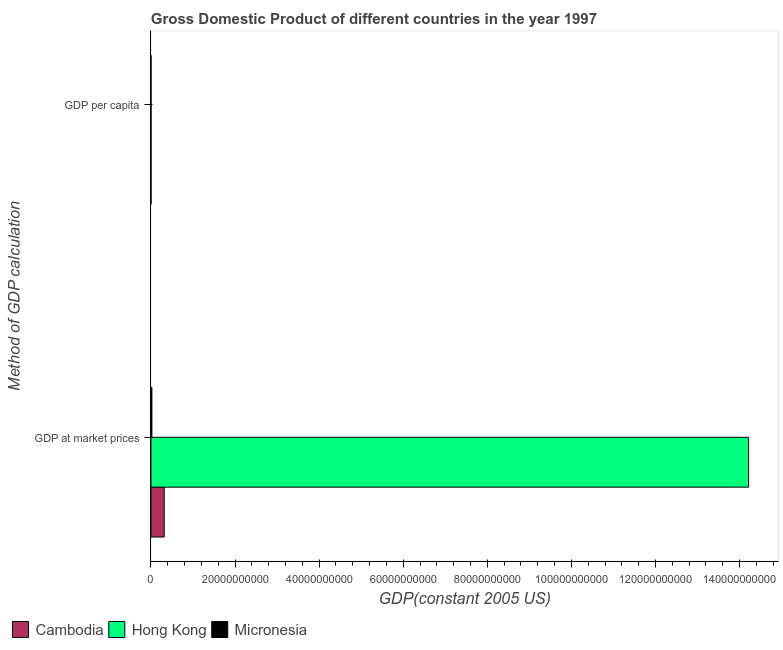How many groups of bars are there?
Give a very brief answer. 2. Are the number of bars per tick equal to the number of legend labels?
Give a very brief answer. Yes. Are the number of bars on each tick of the Y-axis equal?
Give a very brief answer. Yes. What is the label of the 1st group of bars from the top?
Ensure brevity in your answer.  GDP per capita. What is the gdp at market prices in Micronesia?
Your answer should be very brief. 2.22e+08. Across all countries, what is the maximum gdp per capita?
Make the answer very short. 2.19e+04. Across all countries, what is the minimum gdp per capita?
Offer a terse response. 277.83. In which country was the gdp at market prices maximum?
Make the answer very short. Hong Kong. In which country was the gdp per capita minimum?
Make the answer very short. Cambodia. What is the total gdp per capita in the graph?
Give a very brief answer. 2.42e+04. What is the difference between the gdp at market prices in Micronesia and that in Hong Kong?
Offer a terse response. -1.42e+11. What is the difference between the gdp at market prices in Cambodia and the gdp per capita in Hong Kong?
Your answer should be very brief. 3.15e+09. What is the average gdp per capita per country?
Your answer should be compact. 8076.57. What is the difference between the gdp per capita and gdp at market prices in Cambodia?
Ensure brevity in your answer.  -3.15e+09. What is the ratio of the gdp per capita in Micronesia to that in Hong Kong?
Keep it short and to the point. 0.09. Is the gdp at market prices in Hong Kong less than that in Micronesia?
Give a very brief answer. No. In how many countries, is the gdp at market prices greater than the average gdp at market prices taken over all countries?
Give a very brief answer. 1. What does the 1st bar from the top in GDP at market prices represents?
Keep it short and to the point. Micronesia. What does the 2nd bar from the bottom in GDP per capita represents?
Provide a succinct answer. Hong Kong. How many bars are there?
Keep it short and to the point. 6. Does the graph contain grids?
Keep it short and to the point. No. Where does the legend appear in the graph?
Make the answer very short. Bottom left. How many legend labels are there?
Offer a terse response. 3. How are the legend labels stacked?
Your answer should be very brief. Horizontal. What is the title of the graph?
Provide a short and direct response. Gross Domestic Product of different countries in the year 1997. What is the label or title of the X-axis?
Your answer should be compact. GDP(constant 2005 US). What is the label or title of the Y-axis?
Provide a succinct answer. Method of GDP calculation. What is the GDP(constant 2005 US) of Cambodia in GDP at market prices?
Make the answer very short. 3.15e+09. What is the GDP(constant 2005 US) in Hong Kong in GDP at market prices?
Your answer should be compact. 1.42e+11. What is the GDP(constant 2005 US) of Micronesia in GDP at market prices?
Offer a terse response. 2.22e+08. What is the GDP(constant 2005 US) of Cambodia in GDP per capita?
Provide a succinct answer. 277.83. What is the GDP(constant 2005 US) of Hong Kong in GDP per capita?
Offer a very short reply. 2.19e+04. What is the GDP(constant 2005 US) of Micronesia in GDP per capita?
Your response must be concise. 2047.5. Across all Method of GDP calculation, what is the maximum GDP(constant 2005 US) in Cambodia?
Your answer should be compact. 3.15e+09. Across all Method of GDP calculation, what is the maximum GDP(constant 2005 US) in Hong Kong?
Offer a very short reply. 1.42e+11. Across all Method of GDP calculation, what is the maximum GDP(constant 2005 US) of Micronesia?
Make the answer very short. 2.22e+08. Across all Method of GDP calculation, what is the minimum GDP(constant 2005 US) of Cambodia?
Provide a short and direct response. 277.83. Across all Method of GDP calculation, what is the minimum GDP(constant 2005 US) of Hong Kong?
Ensure brevity in your answer.  2.19e+04. Across all Method of GDP calculation, what is the minimum GDP(constant 2005 US) in Micronesia?
Ensure brevity in your answer.  2047.5. What is the total GDP(constant 2005 US) of Cambodia in the graph?
Provide a short and direct response. 3.15e+09. What is the total GDP(constant 2005 US) of Hong Kong in the graph?
Offer a very short reply. 1.42e+11. What is the total GDP(constant 2005 US) of Micronesia in the graph?
Make the answer very short. 2.22e+08. What is the difference between the GDP(constant 2005 US) in Cambodia in GDP at market prices and that in GDP per capita?
Provide a short and direct response. 3.15e+09. What is the difference between the GDP(constant 2005 US) in Hong Kong in GDP at market prices and that in GDP per capita?
Offer a terse response. 1.42e+11. What is the difference between the GDP(constant 2005 US) in Micronesia in GDP at market prices and that in GDP per capita?
Your response must be concise. 2.22e+08. What is the difference between the GDP(constant 2005 US) of Cambodia in GDP at market prices and the GDP(constant 2005 US) of Hong Kong in GDP per capita?
Give a very brief answer. 3.15e+09. What is the difference between the GDP(constant 2005 US) in Cambodia in GDP at market prices and the GDP(constant 2005 US) in Micronesia in GDP per capita?
Provide a succinct answer. 3.15e+09. What is the difference between the GDP(constant 2005 US) in Hong Kong in GDP at market prices and the GDP(constant 2005 US) in Micronesia in GDP per capita?
Your answer should be very brief. 1.42e+11. What is the average GDP(constant 2005 US) of Cambodia per Method of GDP calculation?
Ensure brevity in your answer.  1.58e+09. What is the average GDP(constant 2005 US) of Hong Kong per Method of GDP calculation?
Offer a terse response. 7.11e+1. What is the average GDP(constant 2005 US) in Micronesia per Method of GDP calculation?
Give a very brief answer. 1.11e+08. What is the difference between the GDP(constant 2005 US) of Cambodia and GDP(constant 2005 US) of Hong Kong in GDP at market prices?
Offer a very short reply. -1.39e+11. What is the difference between the GDP(constant 2005 US) in Cambodia and GDP(constant 2005 US) in Micronesia in GDP at market prices?
Your response must be concise. 2.93e+09. What is the difference between the GDP(constant 2005 US) in Hong Kong and GDP(constant 2005 US) in Micronesia in GDP at market prices?
Your answer should be very brief. 1.42e+11. What is the difference between the GDP(constant 2005 US) in Cambodia and GDP(constant 2005 US) in Hong Kong in GDP per capita?
Ensure brevity in your answer.  -2.16e+04. What is the difference between the GDP(constant 2005 US) of Cambodia and GDP(constant 2005 US) of Micronesia in GDP per capita?
Offer a very short reply. -1769.67. What is the difference between the GDP(constant 2005 US) of Hong Kong and GDP(constant 2005 US) of Micronesia in GDP per capita?
Provide a succinct answer. 1.99e+04. What is the ratio of the GDP(constant 2005 US) in Cambodia in GDP at market prices to that in GDP per capita?
Give a very brief answer. 1.13e+07. What is the ratio of the GDP(constant 2005 US) of Hong Kong in GDP at market prices to that in GDP per capita?
Your response must be concise. 6.49e+06. What is the ratio of the GDP(constant 2005 US) of Micronesia in GDP at market prices to that in GDP per capita?
Offer a very short reply. 1.09e+05. What is the difference between the highest and the second highest GDP(constant 2005 US) in Cambodia?
Offer a very short reply. 3.15e+09. What is the difference between the highest and the second highest GDP(constant 2005 US) in Hong Kong?
Offer a very short reply. 1.42e+11. What is the difference between the highest and the second highest GDP(constant 2005 US) of Micronesia?
Keep it short and to the point. 2.22e+08. What is the difference between the highest and the lowest GDP(constant 2005 US) of Cambodia?
Your answer should be compact. 3.15e+09. What is the difference between the highest and the lowest GDP(constant 2005 US) in Hong Kong?
Provide a succinct answer. 1.42e+11. What is the difference between the highest and the lowest GDP(constant 2005 US) of Micronesia?
Your response must be concise. 2.22e+08. 